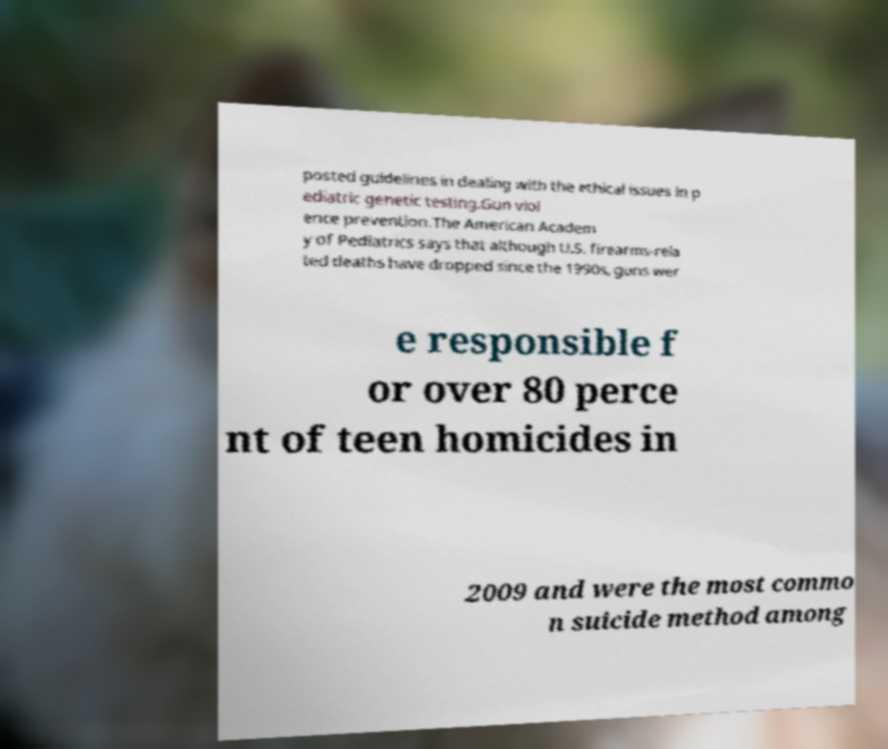Can you read and provide the text displayed in the image?This photo seems to have some interesting text. Can you extract and type it out for me? posted guidelines in dealing with the ethical issues in p ediatric genetic testing.Gun viol ence prevention.The American Academ y of Pediatrics says that although U.S. firearms-rela ted deaths have dropped since the 1990s, guns wer e responsible f or over 80 perce nt of teen homicides in 2009 and were the most commo n suicide method among 